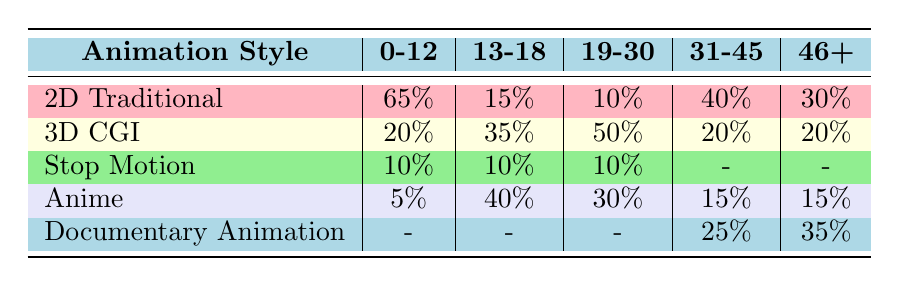What is the percentage preference for 2D Traditional animation in the 0-12 age group? The table shows that the preference percentage for 2D Traditional animation in the 0-12 age group is listed directly under the 0-12 column for that row, which is 65%.
Answer: 65% Which animation style has the highest preference percentage among the 19-30 age group? Reviewing the 19-30 age group row, 3D CGI has the highest preference at 50%, compared to Anime (30%), 2D Traditional (10%), and Stop Motion (10%).
Answer: 3D CGI Is there any age group that prefers Stop Motion animation more than 10%? The table shows that the preference for Stop Motion animation is listed as 10% for the 0-12, 13-18, and 19-30 age groups, but there is no age group with a preference greater than 10%.
Answer: No What is the total percentage preference for Anime across all age groups? To find this, we add the preference percentages for Anime in all age groups: 5% (0-12) + 40% (13-18) + 30% (19-30) + 15% (31-45) + 15% (46+) = 105%.
Answer: 105% Which age group has the lowest preference for 2D Traditional animation? The table shows that the 2D Traditional animation preference for age groups is 65% (0-12), 15% (13-18), 10% (19-30), 40% (31-45), and 30% (46+). The lowest is 10% for the 19-30 age group.
Answer: 19-30 How does the preference for Documentary Animation change across age groups? The preference for Documentary Animation appears only in the 31-45 age group (25%) and the 46+ age group (35%), indicating there is no preference in the other age groups. This suggests that it becomes more favored as age increases.
Answer: Increases Is the preference for 3D CGI animation greater in the 13-18 age group than in the 31-45 age group? The preference for 3D CGI is 35% in the 13-18 age group and 20% in the 31-45 age group. Since 35% is greater than 20%, the answer is yes.
Answer: Yes What percentage of the 46+ age group prefers 2D Traditional animation compared to those that prefer Documentary Animation? For the 46+ age group, the preference for 2D Traditional animation is 30%, while Documentary Animation is 35%. Since 30% is less than 35%, the answer is that fewer prefer 2D Traditional animation.
Answer: Fewer prefer 2D Traditional Which animation style has a constant preference across all age groups? Upon checking each row, it is evident that Stop Motion only appears with the same preference of 10% in the 0-12, 13-18, and 19-30 age groups, but it doesn't have a preference listed in 31-45 and 46+. Thus, there isn't any style with a constant preference across all age groups.
Answer: None 